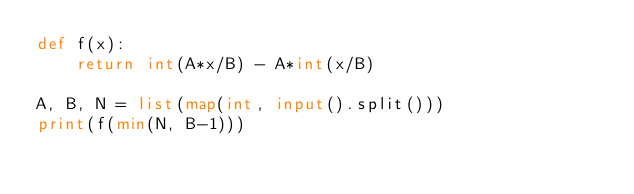Convert code to text. <code><loc_0><loc_0><loc_500><loc_500><_Python_>def f(x):
    return int(A*x/B) - A*int(x/B)

A, B, N = list(map(int, input().split()))
print(f(min(N, B-1)))</code> 